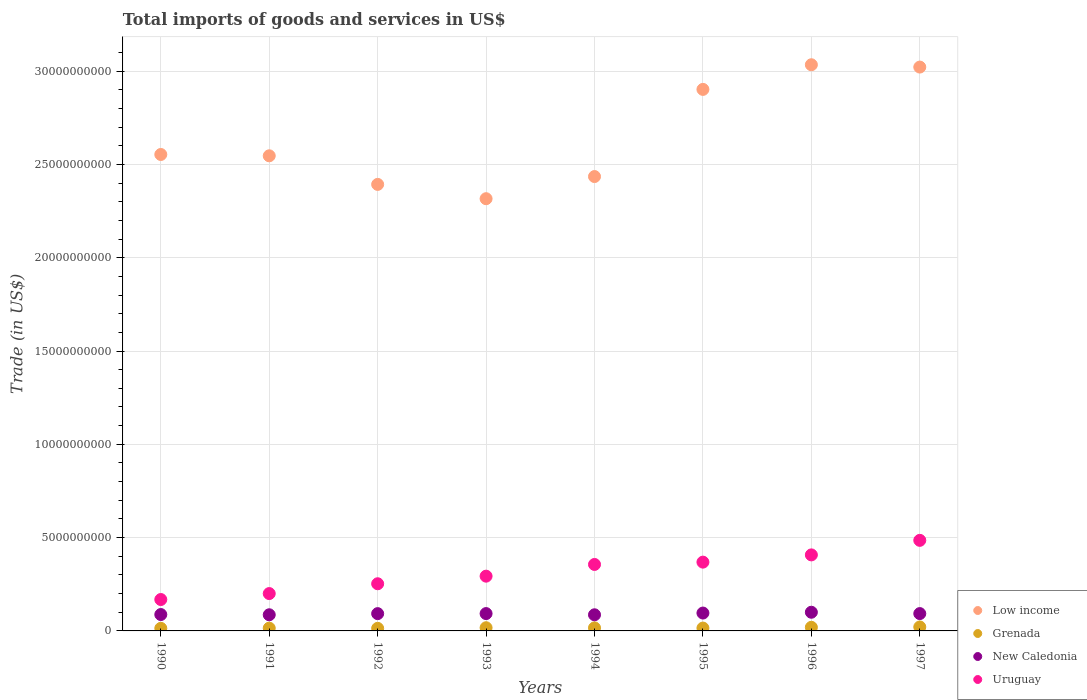What is the total imports of goods and services in Uruguay in 1991?
Offer a terse response. 2.00e+09. Across all years, what is the maximum total imports of goods and services in New Caledonia?
Offer a very short reply. 1.00e+09. Across all years, what is the minimum total imports of goods and services in New Caledonia?
Keep it short and to the point. 8.65e+08. In which year was the total imports of goods and services in New Caledonia minimum?
Offer a terse response. 1994. What is the total total imports of goods and services in Uruguay in the graph?
Your answer should be compact. 2.53e+1. What is the difference between the total imports of goods and services in Low income in 1994 and that in 1997?
Make the answer very short. -5.87e+09. What is the difference between the total imports of goods and services in Low income in 1993 and the total imports of goods and services in New Caledonia in 1995?
Your response must be concise. 2.22e+1. What is the average total imports of goods and services in Grenada per year?
Keep it short and to the point. 1.65e+08. In the year 1992, what is the difference between the total imports of goods and services in Uruguay and total imports of goods and services in Low income?
Provide a succinct answer. -2.14e+1. What is the ratio of the total imports of goods and services in Grenada in 1994 to that in 1996?
Ensure brevity in your answer.  0.84. Is the difference between the total imports of goods and services in Uruguay in 1992 and 1995 greater than the difference between the total imports of goods and services in Low income in 1992 and 1995?
Your response must be concise. Yes. What is the difference between the highest and the second highest total imports of goods and services in Grenada?
Give a very brief answer. 1.94e+07. What is the difference between the highest and the lowest total imports of goods and services in Grenada?
Keep it short and to the point. 7.43e+07. Is the total imports of goods and services in New Caledonia strictly less than the total imports of goods and services in Low income over the years?
Your response must be concise. Yes. How many dotlines are there?
Provide a short and direct response. 4. How many years are there in the graph?
Your answer should be very brief. 8. What is the difference between two consecutive major ticks on the Y-axis?
Offer a terse response. 5.00e+09. Are the values on the major ticks of Y-axis written in scientific E-notation?
Make the answer very short. No. Does the graph contain grids?
Make the answer very short. Yes. How many legend labels are there?
Provide a succinct answer. 4. How are the legend labels stacked?
Make the answer very short. Vertical. What is the title of the graph?
Offer a very short reply. Total imports of goods and services in US$. Does "Curacao" appear as one of the legend labels in the graph?
Offer a terse response. No. What is the label or title of the Y-axis?
Make the answer very short. Trade (in US$). What is the Trade (in US$) in Low income in 1990?
Make the answer very short. 2.55e+1. What is the Trade (in US$) of Grenada in 1990?
Offer a very short reply. 1.39e+08. What is the Trade (in US$) of New Caledonia in 1990?
Your answer should be compact. 8.78e+08. What is the Trade (in US$) of Uruguay in 1990?
Ensure brevity in your answer.  1.68e+09. What is the Trade (in US$) of Low income in 1991?
Provide a succinct answer. 2.55e+1. What is the Trade (in US$) in Grenada in 1991?
Provide a succinct answer. 1.49e+08. What is the Trade (in US$) of New Caledonia in 1991?
Keep it short and to the point. 8.66e+08. What is the Trade (in US$) of Uruguay in 1991?
Your response must be concise. 2.00e+09. What is the Trade (in US$) of Low income in 1992?
Keep it short and to the point. 2.39e+1. What is the Trade (in US$) of Grenada in 1992?
Offer a terse response. 1.38e+08. What is the Trade (in US$) of New Caledonia in 1992?
Keep it short and to the point. 9.26e+08. What is the Trade (in US$) in Uruguay in 1992?
Your answer should be very brief. 2.53e+09. What is the Trade (in US$) in Low income in 1993?
Provide a succinct answer. 2.32e+1. What is the Trade (in US$) in Grenada in 1993?
Ensure brevity in your answer.  1.70e+08. What is the Trade (in US$) in New Caledonia in 1993?
Ensure brevity in your answer.  9.29e+08. What is the Trade (in US$) of Uruguay in 1993?
Keep it short and to the point. 2.93e+09. What is the Trade (in US$) in Low income in 1994?
Your response must be concise. 2.43e+1. What is the Trade (in US$) in Grenada in 1994?
Provide a short and direct response. 1.63e+08. What is the Trade (in US$) of New Caledonia in 1994?
Your response must be concise. 8.65e+08. What is the Trade (in US$) of Uruguay in 1994?
Provide a short and direct response. 3.56e+09. What is the Trade (in US$) in Low income in 1995?
Your response must be concise. 2.90e+1. What is the Trade (in US$) in Grenada in 1995?
Provide a succinct answer. 1.53e+08. What is the Trade (in US$) of New Caledonia in 1995?
Offer a terse response. 9.57e+08. What is the Trade (in US$) in Uruguay in 1995?
Ensure brevity in your answer.  3.69e+09. What is the Trade (in US$) of Low income in 1996?
Ensure brevity in your answer.  3.03e+1. What is the Trade (in US$) in Grenada in 1996?
Make the answer very short. 1.93e+08. What is the Trade (in US$) in New Caledonia in 1996?
Keep it short and to the point. 1.00e+09. What is the Trade (in US$) of Uruguay in 1996?
Provide a succinct answer. 4.07e+09. What is the Trade (in US$) of Low income in 1997?
Offer a very short reply. 3.02e+1. What is the Trade (in US$) in Grenada in 1997?
Your answer should be compact. 2.13e+08. What is the Trade (in US$) in New Caledonia in 1997?
Your answer should be compact. 9.29e+08. What is the Trade (in US$) of Uruguay in 1997?
Offer a very short reply. 4.85e+09. Across all years, what is the maximum Trade (in US$) of Low income?
Make the answer very short. 3.03e+1. Across all years, what is the maximum Trade (in US$) of Grenada?
Give a very brief answer. 2.13e+08. Across all years, what is the maximum Trade (in US$) of New Caledonia?
Provide a short and direct response. 1.00e+09. Across all years, what is the maximum Trade (in US$) in Uruguay?
Offer a very short reply. 4.85e+09. Across all years, what is the minimum Trade (in US$) of Low income?
Make the answer very short. 2.32e+1. Across all years, what is the minimum Trade (in US$) of Grenada?
Your response must be concise. 1.38e+08. Across all years, what is the minimum Trade (in US$) in New Caledonia?
Your answer should be very brief. 8.65e+08. Across all years, what is the minimum Trade (in US$) in Uruguay?
Your answer should be compact. 1.68e+09. What is the total Trade (in US$) of Low income in the graph?
Offer a terse response. 2.12e+11. What is the total Trade (in US$) in Grenada in the graph?
Your answer should be compact. 1.32e+09. What is the total Trade (in US$) of New Caledonia in the graph?
Give a very brief answer. 7.35e+09. What is the total Trade (in US$) of Uruguay in the graph?
Offer a terse response. 2.53e+1. What is the difference between the Trade (in US$) in Low income in 1990 and that in 1991?
Ensure brevity in your answer.  7.06e+07. What is the difference between the Trade (in US$) in Grenada in 1990 and that in 1991?
Give a very brief answer. -1.03e+07. What is the difference between the Trade (in US$) in New Caledonia in 1990 and that in 1991?
Keep it short and to the point. 1.24e+07. What is the difference between the Trade (in US$) in Uruguay in 1990 and that in 1991?
Your answer should be compact. -3.19e+08. What is the difference between the Trade (in US$) in Low income in 1990 and that in 1992?
Provide a succinct answer. 1.60e+09. What is the difference between the Trade (in US$) of Grenada in 1990 and that in 1992?
Provide a short and direct response. 5.22e+05. What is the difference between the Trade (in US$) in New Caledonia in 1990 and that in 1992?
Offer a terse response. -4.83e+07. What is the difference between the Trade (in US$) in Uruguay in 1990 and that in 1992?
Offer a terse response. -8.45e+08. What is the difference between the Trade (in US$) of Low income in 1990 and that in 1993?
Ensure brevity in your answer.  2.37e+09. What is the difference between the Trade (in US$) in Grenada in 1990 and that in 1993?
Offer a very short reply. -3.16e+07. What is the difference between the Trade (in US$) of New Caledonia in 1990 and that in 1993?
Your answer should be very brief. -5.12e+07. What is the difference between the Trade (in US$) in Uruguay in 1990 and that in 1993?
Your answer should be very brief. -1.25e+09. What is the difference between the Trade (in US$) in Low income in 1990 and that in 1994?
Give a very brief answer. 1.18e+09. What is the difference between the Trade (in US$) of Grenada in 1990 and that in 1994?
Keep it short and to the point. -2.40e+07. What is the difference between the Trade (in US$) of New Caledonia in 1990 and that in 1994?
Make the answer very short. 1.31e+07. What is the difference between the Trade (in US$) in Uruguay in 1990 and that in 1994?
Make the answer very short. -1.88e+09. What is the difference between the Trade (in US$) in Low income in 1990 and that in 1995?
Your answer should be very brief. -3.49e+09. What is the difference between the Trade (in US$) in Grenada in 1990 and that in 1995?
Give a very brief answer. -1.39e+07. What is the difference between the Trade (in US$) in New Caledonia in 1990 and that in 1995?
Your answer should be very brief. -7.95e+07. What is the difference between the Trade (in US$) of Uruguay in 1990 and that in 1995?
Offer a terse response. -2.00e+09. What is the difference between the Trade (in US$) of Low income in 1990 and that in 1996?
Give a very brief answer. -4.81e+09. What is the difference between the Trade (in US$) in Grenada in 1990 and that in 1996?
Ensure brevity in your answer.  -5.44e+07. What is the difference between the Trade (in US$) in New Caledonia in 1990 and that in 1996?
Keep it short and to the point. -1.23e+08. What is the difference between the Trade (in US$) of Uruguay in 1990 and that in 1996?
Ensure brevity in your answer.  -2.39e+09. What is the difference between the Trade (in US$) in Low income in 1990 and that in 1997?
Provide a short and direct response. -4.68e+09. What is the difference between the Trade (in US$) in Grenada in 1990 and that in 1997?
Offer a very short reply. -7.38e+07. What is the difference between the Trade (in US$) of New Caledonia in 1990 and that in 1997?
Ensure brevity in your answer.  -5.09e+07. What is the difference between the Trade (in US$) of Uruguay in 1990 and that in 1997?
Your answer should be very brief. -3.17e+09. What is the difference between the Trade (in US$) in Low income in 1991 and that in 1992?
Keep it short and to the point. 1.53e+09. What is the difference between the Trade (in US$) in Grenada in 1991 and that in 1992?
Offer a terse response. 1.08e+07. What is the difference between the Trade (in US$) of New Caledonia in 1991 and that in 1992?
Your answer should be compact. -6.07e+07. What is the difference between the Trade (in US$) of Uruguay in 1991 and that in 1992?
Your answer should be compact. -5.26e+08. What is the difference between the Trade (in US$) in Low income in 1991 and that in 1993?
Offer a terse response. 2.30e+09. What is the difference between the Trade (in US$) of Grenada in 1991 and that in 1993?
Offer a terse response. -2.13e+07. What is the difference between the Trade (in US$) in New Caledonia in 1991 and that in 1993?
Offer a very short reply. -6.36e+07. What is the difference between the Trade (in US$) in Uruguay in 1991 and that in 1993?
Ensure brevity in your answer.  -9.33e+08. What is the difference between the Trade (in US$) in Low income in 1991 and that in 1994?
Provide a succinct answer. 1.11e+09. What is the difference between the Trade (in US$) of Grenada in 1991 and that in 1994?
Provide a succinct answer. -1.37e+07. What is the difference between the Trade (in US$) in New Caledonia in 1991 and that in 1994?
Your answer should be compact. 7.38e+05. What is the difference between the Trade (in US$) of Uruguay in 1991 and that in 1994?
Provide a succinct answer. -1.56e+09. What is the difference between the Trade (in US$) in Low income in 1991 and that in 1995?
Ensure brevity in your answer.  -3.56e+09. What is the difference between the Trade (in US$) in Grenada in 1991 and that in 1995?
Your answer should be very brief. -3.58e+06. What is the difference between the Trade (in US$) in New Caledonia in 1991 and that in 1995?
Ensure brevity in your answer.  -9.19e+07. What is the difference between the Trade (in US$) in Uruguay in 1991 and that in 1995?
Provide a succinct answer. -1.68e+09. What is the difference between the Trade (in US$) in Low income in 1991 and that in 1996?
Provide a short and direct response. -4.88e+09. What is the difference between the Trade (in US$) in Grenada in 1991 and that in 1996?
Provide a succinct answer. -4.41e+07. What is the difference between the Trade (in US$) in New Caledonia in 1991 and that in 1996?
Make the answer very short. -1.35e+08. What is the difference between the Trade (in US$) of Uruguay in 1991 and that in 1996?
Provide a short and direct response. -2.07e+09. What is the difference between the Trade (in US$) in Low income in 1991 and that in 1997?
Give a very brief answer. -4.75e+09. What is the difference between the Trade (in US$) of Grenada in 1991 and that in 1997?
Your response must be concise. -6.35e+07. What is the difference between the Trade (in US$) of New Caledonia in 1991 and that in 1997?
Give a very brief answer. -6.32e+07. What is the difference between the Trade (in US$) of Uruguay in 1991 and that in 1997?
Provide a short and direct response. -2.85e+09. What is the difference between the Trade (in US$) of Low income in 1992 and that in 1993?
Make the answer very short. 7.67e+08. What is the difference between the Trade (in US$) of Grenada in 1992 and that in 1993?
Your answer should be compact. -3.21e+07. What is the difference between the Trade (in US$) in New Caledonia in 1992 and that in 1993?
Provide a succinct answer. -2.90e+06. What is the difference between the Trade (in US$) in Uruguay in 1992 and that in 1993?
Offer a terse response. -4.07e+08. What is the difference between the Trade (in US$) in Low income in 1992 and that in 1994?
Give a very brief answer. -4.20e+08. What is the difference between the Trade (in US$) in Grenada in 1992 and that in 1994?
Offer a very short reply. -2.45e+07. What is the difference between the Trade (in US$) in New Caledonia in 1992 and that in 1994?
Your answer should be compact. 6.14e+07. What is the difference between the Trade (in US$) in Uruguay in 1992 and that in 1994?
Give a very brief answer. -1.03e+09. What is the difference between the Trade (in US$) in Low income in 1992 and that in 1995?
Your answer should be compact. -5.09e+09. What is the difference between the Trade (in US$) of Grenada in 1992 and that in 1995?
Provide a succinct answer. -1.44e+07. What is the difference between the Trade (in US$) of New Caledonia in 1992 and that in 1995?
Give a very brief answer. -3.12e+07. What is the difference between the Trade (in US$) in Uruguay in 1992 and that in 1995?
Your response must be concise. -1.16e+09. What is the difference between the Trade (in US$) of Low income in 1992 and that in 1996?
Give a very brief answer. -6.41e+09. What is the difference between the Trade (in US$) of Grenada in 1992 and that in 1996?
Your answer should be compact. -5.49e+07. What is the difference between the Trade (in US$) of New Caledonia in 1992 and that in 1996?
Offer a very short reply. -7.45e+07. What is the difference between the Trade (in US$) of Uruguay in 1992 and that in 1996?
Your answer should be very brief. -1.55e+09. What is the difference between the Trade (in US$) of Low income in 1992 and that in 1997?
Make the answer very short. -6.29e+09. What is the difference between the Trade (in US$) of Grenada in 1992 and that in 1997?
Provide a succinct answer. -7.43e+07. What is the difference between the Trade (in US$) in New Caledonia in 1992 and that in 1997?
Give a very brief answer. -2.57e+06. What is the difference between the Trade (in US$) of Uruguay in 1992 and that in 1997?
Offer a very short reply. -2.33e+09. What is the difference between the Trade (in US$) in Low income in 1993 and that in 1994?
Provide a succinct answer. -1.19e+09. What is the difference between the Trade (in US$) of Grenada in 1993 and that in 1994?
Offer a terse response. 7.60e+06. What is the difference between the Trade (in US$) in New Caledonia in 1993 and that in 1994?
Give a very brief answer. 6.43e+07. What is the difference between the Trade (in US$) in Uruguay in 1993 and that in 1994?
Offer a terse response. -6.27e+08. What is the difference between the Trade (in US$) in Low income in 1993 and that in 1995?
Provide a succinct answer. -5.86e+09. What is the difference between the Trade (in US$) in Grenada in 1993 and that in 1995?
Keep it short and to the point. 1.77e+07. What is the difference between the Trade (in US$) of New Caledonia in 1993 and that in 1995?
Your answer should be compact. -2.83e+07. What is the difference between the Trade (in US$) in Uruguay in 1993 and that in 1995?
Keep it short and to the point. -7.52e+08. What is the difference between the Trade (in US$) of Low income in 1993 and that in 1996?
Your answer should be very brief. -7.18e+09. What is the difference between the Trade (in US$) in Grenada in 1993 and that in 1996?
Provide a succinct answer. -2.28e+07. What is the difference between the Trade (in US$) of New Caledonia in 1993 and that in 1996?
Your answer should be compact. -7.16e+07. What is the difference between the Trade (in US$) of Uruguay in 1993 and that in 1996?
Give a very brief answer. -1.14e+09. What is the difference between the Trade (in US$) in Low income in 1993 and that in 1997?
Give a very brief answer. -7.05e+09. What is the difference between the Trade (in US$) in Grenada in 1993 and that in 1997?
Your answer should be compact. -4.22e+07. What is the difference between the Trade (in US$) of New Caledonia in 1993 and that in 1997?
Give a very brief answer. 3.37e+05. What is the difference between the Trade (in US$) of Uruguay in 1993 and that in 1997?
Your answer should be compact. -1.92e+09. What is the difference between the Trade (in US$) in Low income in 1994 and that in 1995?
Your answer should be very brief. -4.67e+09. What is the difference between the Trade (in US$) in Grenada in 1994 and that in 1995?
Ensure brevity in your answer.  1.01e+07. What is the difference between the Trade (in US$) in New Caledonia in 1994 and that in 1995?
Provide a short and direct response. -9.26e+07. What is the difference between the Trade (in US$) of Uruguay in 1994 and that in 1995?
Your answer should be very brief. -1.24e+08. What is the difference between the Trade (in US$) in Low income in 1994 and that in 1996?
Keep it short and to the point. -5.99e+09. What is the difference between the Trade (in US$) in Grenada in 1994 and that in 1996?
Offer a terse response. -3.04e+07. What is the difference between the Trade (in US$) of New Caledonia in 1994 and that in 1996?
Make the answer very short. -1.36e+08. What is the difference between the Trade (in US$) of Uruguay in 1994 and that in 1996?
Offer a terse response. -5.12e+08. What is the difference between the Trade (in US$) of Low income in 1994 and that in 1997?
Give a very brief answer. -5.87e+09. What is the difference between the Trade (in US$) in Grenada in 1994 and that in 1997?
Provide a short and direct response. -4.98e+07. What is the difference between the Trade (in US$) of New Caledonia in 1994 and that in 1997?
Your response must be concise. -6.40e+07. What is the difference between the Trade (in US$) in Uruguay in 1994 and that in 1997?
Offer a very short reply. -1.29e+09. What is the difference between the Trade (in US$) in Low income in 1995 and that in 1996?
Provide a succinct answer. -1.32e+09. What is the difference between the Trade (in US$) of Grenada in 1995 and that in 1996?
Offer a very short reply. -4.05e+07. What is the difference between the Trade (in US$) of New Caledonia in 1995 and that in 1996?
Make the answer very short. -4.34e+07. What is the difference between the Trade (in US$) of Uruguay in 1995 and that in 1996?
Provide a short and direct response. -3.88e+08. What is the difference between the Trade (in US$) of Low income in 1995 and that in 1997?
Offer a terse response. -1.20e+09. What is the difference between the Trade (in US$) of Grenada in 1995 and that in 1997?
Your response must be concise. -5.99e+07. What is the difference between the Trade (in US$) of New Caledonia in 1995 and that in 1997?
Your answer should be very brief. 2.86e+07. What is the difference between the Trade (in US$) of Uruguay in 1995 and that in 1997?
Your answer should be very brief. -1.17e+09. What is the difference between the Trade (in US$) of Low income in 1996 and that in 1997?
Your answer should be compact. 1.24e+08. What is the difference between the Trade (in US$) in Grenada in 1996 and that in 1997?
Provide a succinct answer. -1.94e+07. What is the difference between the Trade (in US$) of New Caledonia in 1996 and that in 1997?
Your answer should be very brief. 7.20e+07. What is the difference between the Trade (in US$) of Uruguay in 1996 and that in 1997?
Make the answer very short. -7.79e+08. What is the difference between the Trade (in US$) of Low income in 1990 and the Trade (in US$) of Grenada in 1991?
Give a very brief answer. 2.54e+1. What is the difference between the Trade (in US$) of Low income in 1990 and the Trade (in US$) of New Caledonia in 1991?
Provide a short and direct response. 2.47e+1. What is the difference between the Trade (in US$) of Low income in 1990 and the Trade (in US$) of Uruguay in 1991?
Offer a very short reply. 2.35e+1. What is the difference between the Trade (in US$) of Grenada in 1990 and the Trade (in US$) of New Caledonia in 1991?
Provide a short and direct response. -7.27e+08. What is the difference between the Trade (in US$) in Grenada in 1990 and the Trade (in US$) in Uruguay in 1991?
Ensure brevity in your answer.  -1.86e+09. What is the difference between the Trade (in US$) of New Caledonia in 1990 and the Trade (in US$) of Uruguay in 1991?
Keep it short and to the point. -1.12e+09. What is the difference between the Trade (in US$) of Low income in 1990 and the Trade (in US$) of Grenada in 1992?
Ensure brevity in your answer.  2.54e+1. What is the difference between the Trade (in US$) in Low income in 1990 and the Trade (in US$) in New Caledonia in 1992?
Your answer should be compact. 2.46e+1. What is the difference between the Trade (in US$) of Low income in 1990 and the Trade (in US$) of Uruguay in 1992?
Provide a short and direct response. 2.30e+1. What is the difference between the Trade (in US$) in Grenada in 1990 and the Trade (in US$) in New Caledonia in 1992?
Offer a very short reply. -7.87e+08. What is the difference between the Trade (in US$) in Grenada in 1990 and the Trade (in US$) in Uruguay in 1992?
Your answer should be compact. -2.39e+09. What is the difference between the Trade (in US$) in New Caledonia in 1990 and the Trade (in US$) in Uruguay in 1992?
Offer a terse response. -1.65e+09. What is the difference between the Trade (in US$) of Low income in 1990 and the Trade (in US$) of Grenada in 1993?
Your answer should be very brief. 2.54e+1. What is the difference between the Trade (in US$) in Low income in 1990 and the Trade (in US$) in New Caledonia in 1993?
Ensure brevity in your answer.  2.46e+1. What is the difference between the Trade (in US$) of Low income in 1990 and the Trade (in US$) of Uruguay in 1993?
Your answer should be very brief. 2.26e+1. What is the difference between the Trade (in US$) of Grenada in 1990 and the Trade (in US$) of New Caledonia in 1993?
Give a very brief answer. -7.90e+08. What is the difference between the Trade (in US$) of Grenada in 1990 and the Trade (in US$) of Uruguay in 1993?
Keep it short and to the point. -2.80e+09. What is the difference between the Trade (in US$) of New Caledonia in 1990 and the Trade (in US$) of Uruguay in 1993?
Give a very brief answer. -2.06e+09. What is the difference between the Trade (in US$) of Low income in 1990 and the Trade (in US$) of Grenada in 1994?
Ensure brevity in your answer.  2.54e+1. What is the difference between the Trade (in US$) of Low income in 1990 and the Trade (in US$) of New Caledonia in 1994?
Keep it short and to the point. 2.47e+1. What is the difference between the Trade (in US$) of Low income in 1990 and the Trade (in US$) of Uruguay in 1994?
Ensure brevity in your answer.  2.20e+1. What is the difference between the Trade (in US$) of Grenada in 1990 and the Trade (in US$) of New Caledonia in 1994?
Make the answer very short. -7.26e+08. What is the difference between the Trade (in US$) of Grenada in 1990 and the Trade (in US$) of Uruguay in 1994?
Your response must be concise. -3.42e+09. What is the difference between the Trade (in US$) of New Caledonia in 1990 and the Trade (in US$) of Uruguay in 1994?
Give a very brief answer. -2.68e+09. What is the difference between the Trade (in US$) of Low income in 1990 and the Trade (in US$) of Grenada in 1995?
Your response must be concise. 2.54e+1. What is the difference between the Trade (in US$) in Low income in 1990 and the Trade (in US$) in New Caledonia in 1995?
Your answer should be very brief. 2.46e+1. What is the difference between the Trade (in US$) of Low income in 1990 and the Trade (in US$) of Uruguay in 1995?
Give a very brief answer. 2.18e+1. What is the difference between the Trade (in US$) of Grenada in 1990 and the Trade (in US$) of New Caledonia in 1995?
Your response must be concise. -8.19e+08. What is the difference between the Trade (in US$) in Grenada in 1990 and the Trade (in US$) in Uruguay in 1995?
Keep it short and to the point. -3.55e+09. What is the difference between the Trade (in US$) in New Caledonia in 1990 and the Trade (in US$) in Uruguay in 1995?
Provide a short and direct response. -2.81e+09. What is the difference between the Trade (in US$) in Low income in 1990 and the Trade (in US$) in Grenada in 1996?
Your response must be concise. 2.53e+1. What is the difference between the Trade (in US$) in Low income in 1990 and the Trade (in US$) in New Caledonia in 1996?
Provide a short and direct response. 2.45e+1. What is the difference between the Trade (in US$) of Low income in 1990 and the Trade (in US$) of Uruguay in 1996?
Ensure brevity in your answer.  2.15e+1. What is the difference between the Trade (in US$) of Grenada in 1990 and the Trade (in US$) of New Caledonia in 1996?
Offer a terse response. -8.62e+08. What is the difference between the Trade (in US$) in Grenada in 1990 and the Trade (in US$) in Uruguay in 1996?
Your answer should be very brief. -3.94e+09. What is the difference between the Trade (in US$) in New Caledonia in 1990 and the Trade (in US$) in Uruguay in 1996?
Offer a terse response. -3.20e+09. What is the difference between the Trade (in US$) of Low income in 1990 and the Trade (in US$) of Grenada in 1997?
Offer a very short reply. 2.53e+1. What is the difference between the Trade (in US$) of Low income in 1990 and the Trade (in US$) of New Caledonia in 1997?
Offer a very short reply. 2.46e+1. What is the difference between the Trade (in US$) in Low income in 1990 and the Trade (in US$) in Uruguay in 1997?
Provide a succinct answer. 2.07e+1. What is the difference between the Trade (in US$) of Grenada in 1990 and the Trade (in US$) of New Caledonia in 1997?
Ensure brevity in your answer.  -7.90e+08. What is the difference between the Trade (in US$) in Grenada in 1990 and the Trade (in US$) in Uruguay in 1997?
Your answer should be compact. -4.71e+09. What is the difference between the Trade (in US$) of New Caledonia in 1990 and the Trade (in US$) of Uruguay in 1997?
Make the answer very short. -3.98e+09. What is the difference between the Trade (in US$) of Low income in 1991 and the Trade (in US$) of Grenada in 1992?
Provide a short and direct response. 2.53e+1. What is the difference between the Trade (in US$) of Low income in 1991 and the Trade (in US$) of New Caledonia in 1992?
Your answer should be very brief. 2.45e+1. What is the difference between the Trade (in US$) in Low income in 1991 and the Trade (in US$) in Uruguay in 1992?
Ensure brevity in your answer.  2.29e+1. What is the difference between the Trade (in US$) of Grenada in 1991 and the Trade (in US$) of New Caledonia in 1992?
Make the answer very short. -7.77e+08. What is the difference between the Trade (in US$) in Grenada in 1991 and the Trade (in US$) in Uruguay in 1992?
Offer a terse response. -2.38e+09. What is the difference between the Trade (in US$) in New Caledonia in 1991 and the Trade (in US$) in Uruguay in 1992?
Your answer should be very brief. -1.66e+09. What is the difference between the Trade (in US$) of Low income in 1991 and the Trade (in US$) of Grenada in 1993?
Provide a succinct answer. 2.53e+1. What is the difference between the Trade (in US$) of Low income in 1991 and the Trade (in US$) of New Caledonia in 1993?
Keep it short and to the point. 2.45e+1. What is the difference between the Trade (in US$) in Low income in 1991 and the Trade (in US$) in Uruguay in 1993?
Keep it short and to the point. 2.25e+1. What is the difference between the Trade (in US$) in Grenada in 1991 and the Trade (in US$) in New Caledonia in 1993?
Give a very brief answer. -7.80e+08. What is the difference between the Trade (in US$) in Grenada in 1991 and the Trade (in US$) in Uruguay in 1993?
Provide a succinct answer. -2.79e+09. What is the difference between the Trade (in US$) in New Caledonia in 1991 and the Trade (in US$) in Uruguay in 1993?
Your answer should be compact. -2.07e+09. What is the difference between the Trade (in US$) of Low income in 1991 and the Trade (in US$) of Grenada in 1994?
Your response must be concise. 2.53e+1. What is the difference between the Trade (in US$) in Low income in 1991 and the Trade (in US$) in New Caledonia in 1994?
Provide a succinct answer. 2.46e+1. What is the difference between the Trade (in US$) of Low income in 1991 and the Trade (in US$) of Uruguay in 1994?
Keep it short and to the point. 2.19e+1. What is the difference between the Trade (in US$) of Grenada in 1991 and the Trade (in US$) of New Caledonia in 1994?
Give a very brief answer. -7.16e+08. What is the difference between the Trade (in US$) in Grenada in 1991 and the Trade (in US$) in Uruguay in 1994?
Offer a very short reply. -3.41e+09. What is the difference between the Trade (in US$) in New Caledonia in 1991 and the Trade (in US$) in Uruguay in 1994?
Your answer should be compact. -2.70e+09. What is the difference between the Trade (in US$) of Low income in 1991 and the Trade (in US$) of Grenada in 1995?
Your answer should be compact. 2.53e+1. What is the difference between the Trade (in US$) of Low income in 1991 and the Trade (in US$) of New Caledonia in 1995?
Your response must be concise. 2.45e+1. What is the difference between the Trade (in US$) of Low income in 1991 and the Trade (in US$) of Uruguay in 1995?
Offer a very short reply. 2.18e+1. What is the difference between the Trade (in US$) in Grenada in 1991 and the Trade (in US$) in New Caledonia in 1995?
Make the answer very short. -8.08e+08. What is the difference between the Trade (in US$) of Grenada in 1991 and the Trade (in US$) of Uruguay in 1995?
Offer a terse response. -3.54e+09. What is the difference between the Trade (in US$) in New Caledonia in 1991 and the Trade (in US$) in Uruguay in 1995?
Offer a terse response. -2.82e+09. What is the difference between the Trade (in US$) of Low income in 1991 and the Trade (in US$) of Grenada in 1996?
Give a very brief answer. 2.53e+1. What is the difference between the Trade (in US$) in Low income in 1991 and the Trade (in US$) in New Caledonia in 1996?
Make the answer very short. 2.45e+1. What is the difference between the Trade (in US$) in Low income in 1991 and the Trade (in US$) in Uruguay in 1996?
Keep it short and to the point. 2.14e+1. What is the difference between the Trade (in US$) of Grenada in 1991 and the Trade (in US$) of New Caledonia in 1996?
Provide a short and direct response. -8.52e+08. What is the difference between the Trade (in US$) in Grenada in 1991 and the Trade (in US$) in Uruguay in 1996?
Your answer should be very brief. -3.92e+09. What is the difference between the Trade (in US$) of New Caledonia in 1991 and the Trade (in US$) of Uruguay in 1996?
Provide a short and direct response. -3.21e+09. What is the difference between the Trade (in US$) of Low income in 1991 and the Trade (in US$) of Grenada in 1997?
Give a very brief answer. 2.52e+1. What is the difference between the Trade (in US$) of Low income in 1991 and the Trade (in US$) of New Caledonia in 1997?
Keep it short and to the point. 2.45e+1. What is the difference between the Trade (in US$) of Low income in 1991 and the Trade (in US$) of Uruguay in 1997?
Provide a succinct answer. 2.06e+1. What is the difference between the Trade (in US$) in Grenada in 1991 and the Trade (in US$) in New Caledonia in 1997?
Offer a very short reply. -7.80e+08. What is the difference between the Trade (in US$) in Grenada in 1991 and the Trade (in US$) in Uruguay in 1997?
Ensure brevity in your answer.  -4.70e+09. What is the difference between the Trade (in US$) of New Caledonia in 1991 and the Trade (in US$) of Uruguay in 1997?
Keep it short and to the point. -3.99e+09. What is the difference between the Trade (in US$) of Low income in 1992 and the Trade (in US$) of Grenada in 1993?
Your response must be concise. 2.38e+1. What is the difference between the Trade (in US$) in Low income in 1992 and the Trade (in US$) in New Caledonia in 1993?
Your answer should be compact. 2.30e+1. What is the difference between the Trade (in US$) in Low income in 1992 and the Trade (in US$) in Uruguay in 1993?
Give a very brief answer. 2.10e+1. What is the difference between the Trade (in US$) of Grenada in 1992 and the Trade (in US$) of New Caledonia in 1993?
Your answer should be very brief. -7.91e+08. What is the difference between the Trade (in US$) of Grenada in 1992 and the Trade (in US$) of Uruguay in 1993?
Make the answer very short. -2.80e+09. What is the difference between the Trade (in US$) of New Caledonia in 1992 and the Trade (in US$) of Uruguay in 1993?
Your answer should be compact. -2.01e+09. What is the difference between the Trade (in US$) in Low income in 1992 and the Trade (in US$) in Grenada in 1994?
Ensure brevity in your answer.  2.38e+1. What is the difference between the Trade (in US$) of Low income in 1992 and the Trade (in US$) of New Caledonia in 1994?
Make the answer very short. 2.31e+1. What is the difference between the Trade (in US$) in Low income in 1992 and the Trade (in US$) in Uruguay in 1994?
Your answer should be very brief. 2.04e+1. What is the difference between the Trade (in US$) in Grenada in 1992 and the Trade (in US$) in New Caledonia in 1994?
Provide a short and direct response. -7.27e+08. What is the difference between the Trade (in US$) of Grenada in 1992 and the Trade (in US$) of Uruguay in 1994?
Your answer should be very brief. -3.42e+09. What is the difference between the Trade (in US$) of New Caledonia in 1992 and the Trade (in US$) of Uruguay in 1994?
Your answer should be compact. -2.64e+09. What is the difference between the Trade (in US$) in Low income in 1992 and the Trade (in US$) in Grenada in 1995?
Ensure brevity in your answer.  2.38e+1. What is the difference between the Trade (in US$) in Low income in 1992 and the Trade (in US$) in New Caledonia in 1995?
Ensure brevity in your answer.  2.30e+1. What is the difference between the Trade (in US$) of Low income in 1992 and the Trade (in US$) of Uruguay in 1995?
Your answer should be very brief. 2.02e+1. What is the difference between the Trade (in US$) of Grenada in 1992 and the Trade (in US$) of New Caledonia in 1995?
Your response must be concise. -8.19e+08. What is the difference between the Trade (in US$) in Grenada in 1992 and the Trade (in US$) in Uruguay in 1995?
Provide a succinct answer. -3.55e+09. What is the difference between the Trade (in US$) of New Caledonia in 1992 and the Trade (in US$) of Uruguay in 1995?
Ensure brevity in your answer.  -2.76e+09. What is the difference between the Trade (in US$) of Low income in 1992 and the Trade (in US$) of Grenada in 1996?
Provide a short and direct response. 2.37e+1. What is the difference between the Trade (in US$) in Low income in 1992 and the Trade (in US$) in New Caledonia in 1996?
Keep it short and to the point. 2.29e+1. What is the difference between the Trade (in US$) in Low income in 1992 and the Trade (in US$) in Uruguay in 1996?
Make the answer very short. 1.99e+1. What is the difference between the Trade (in US$) of Grenada in 1992 and the Trade (in US$) of New Caledonia in 1996?
Your answer should be compact. -8.63e+08. What is the difference between the Trade (in US$) in Grenada in 1992 and the Trade (in US$) in Uruguay in 1996?
Offer a very short reply. -3.94e+09. What is the difference between the Trade (in US$) in New Caledonia in 1992 and the Trade (in US$) in Uruguay in 1996?
Ensure brevity in your answer.  -3.15e+09. What is the difference between the Trade (in US$) in Low income in 1992 and the Trade (in US$) in Grenada in 1997?
Provide a succinct answer. 2.37e+1. What is the difference between the Trade (in US$) in Low income in 1992 and the Trade (in US$) in New Caledonia in 1997?
Your answer should be very brief. 2.30e+1. What is the difference between the Trade (in US$) of Low income in 1992 and the Trade (in US$) of Uruguay in 1997?
Provide a short and direct response. 1.91e+1. What is the difference between the Trade (in US$) of Grenada in 1992 and the Trade (in US$) of New Caledonia in 1997?
Your answer should be very brief. -7.91e+08. What is the difference between the Trade (in US$) of Grenada in 1992 and the Trade (in US$) of Uruguay in 1997?
Offer a very short reply. -4.72e+09. What is the difference between the Trade (in US$) of New Caledonia in 1992 and the Trade (in US$) of Uruguay in 1997?
Provide a short and direct response. -3.93e+09. What is the difference between the Trade (in US$) in Low income in 1993 and the Trade (in US$) in Grenada in 1994?
Ensure brevity in your answer.  2.30e+1. What is the difference between the Trade (in US$) in Low income in 1993 and the Trade (in US$) in New Caledonia in 1994?
Keep it short and to the point. 2.23e+1. What is the difference between the Trade (in US$) of Low income in 1993 and the Trade (in US$) of Uruguay in 1994?
Your response must be concise. 1.96e+1. What is the difference between the Trade (in US$) of Grenada in 1993 and the Trade (in US$) of New Caledonia in 1994?
Your answer should be very brief. -6.94e+08. What is the difference between the Trade (in US$) in Grenada in 1993 and the Trade (in US$) in Uruguay in 1994?
Your answer should be very brief. -3.39e+09. What is the difference between the Trade (in US$) of New Caledonia in 1993 and the Trade (in US$) of Uruguay in 1994?
Give a very brief answer. -2.63e+09. What is the difference between the Trade (in US$) of Low income in 1993 and the Trade (in US$) of Grenada in 1995?
Your answer should be compact. 2.30e+1. What is the difference between the Trade (in US$) of Low income in 1993 and the Trade (in US$) of New Caledonia in 1995?
Your answer should be compact. 2.22e+1. What is the difference between the Trade (in US$) of Low income in 1993 and the Trade (in US$) of Uruguay in 1995?
Your answer should be very brief. 1.95e+1. What is the difference between the Trade (in US$) of Grenada in 1993 and the Trade (in US$) of New Caledonia in 1995?
Ensure brevity in your answer.  -7.87e+08. What is the difference between the Trade (in US$) in Grenada in 1993 and the Trade (in US$) in Uruguay in 1995?
Make the answer very short. -3.52e+09. What is the difference between the Trade (in US$) of New Caledonia in 1993 and the Trade (in US$) of Uruguay in 1995?
Your answer should be very brief. -2.76e+09. What is the difference between the Trade (in US$) in Low income in 1993 and the Trade (in US$) in Grenada in 1996?
Offer a terse response. 2.30e+1. What is the difference between the Trade (in US$) of Low income in 1993 and the Trade (in US$) of New Caledonia in 1996?
Make the answer very short. 2.22e+1. What is the difference between the Trade (in US$) in Low income in 1993 and the Trade (in US$) in Uruguay in 1996?
Your answer should be very brief. 1.91e+1. What is the difference between the Trade (in US$) of Grenada in 1993 and the Trade (in US$) of New Caledonia in 1996?
Give a very brief answer. -8.30e+08. What is the difference between the Trade (in US$) in Grenada in 1993 and the Trade (in US$) in Uruguay in 1996?
Your answer should be very brief. -3.90e+09. What is the difference between the Trade (in US$) in New Caledonia in 1993 and the Trade (in US$) in Uruguay in 1996?
Offer a terse response. -3.14e+09. What is the difference between the Trade (in US$) in Low income in 1993 and the Trade (in US$) in Grenada in 1997?
Provide a succinct answer. 2.29e+1. What is the difference between the Trade (in US$) in Low income in 1993 and the Trade (in US$) in New Caledonia in 1997?
Make the answer very short. 2.22e+1. What is the difference between the Trade (in US$) of Low income in 1993 and the Trade (in US$) of Uruguay in 1997?
Your answer should be compact. 1.83e+1. What is the difference between the Trade (in US$) in Grenada in 1993 and the Trade (in US$) in New Caledonia in 1997?
Provide a short and direct response. -7.58e+08. What is the difference between the Trade (in US$) in Grenada in 1993 and the Trade (in US$) in Uruguay in 1997?
Your response must be concise. -4.68e+09. What is the difference between the Trade (in US$) of New Caledonia in 1993 and the Trade (in US$) of Uruguay in 1997?
Your answer should be very brief. -3.92e+09. What is the difference between the Trade (in US$) of Low income in 1994 and the Trade (in US$) of Grenada in 1995?
Your response must be concise. 2.42e+1. What is the difference between the Trade (in US$) of Low income in 1994 and the Trade (in US$) of New Caledonia in 1995?
Provide a short and direct response. 2.34e+1. What is the difference between the Trade (in US$) of Low income in 1994 and the Trade (in US$) of Uruguay in 1995?
Make the answer very short. 2.07e+1. What is the difference between the Trade (in US$) in Grenada in 1994 and the Trade (in US$) in New Caledonia in 1995?
Ensure brevity in your answer.  -7.95e+08. What is the difference between the Trade (in US$) of Grenada in 1994 and the Trade (in US$) of Uruguay in 1995?
Your answer should be compact. -3.52e+09. What is the difference between the Trade (in US$) of New Caledonia in 1994 and the Trade (in US$) of Uruguay in 1995?
Ensure brevity in your answer.  -2.82e+09. What is the difference between the Trade (in US$) of Low income in 1994 and the Trade (in US$) of Grenada in 1996?
Provide a succinct answer. 2.42e+1. What is the difference between the Trade (in US$) in Low income in 1994 and the Trade (in US$) in New Caledonia in 1996?
Ensure brevity in your answer.  2.33e+1. What is the difference between the Trade (in US$) in Low income in 1994 and the Trade (in US$) in Uruguay in 1996?
Ensure brevity in your answer.  2.03e+1. What is the difference between the Trade (in US$) of Grenada in 1994 and the Trade (in US$) of New Caledonia in 1996?
Ensure brevity in your answer.  -8.38e+08. What is the difference between the Trade (in US$) in Grenada in 1994 and the Trade (in US$) in Uruguay in 1996?
Keep it short and to the point. -3.91e+09. What is the difference between the Trade (in US$) of New Caledonia in 1994 and the Trade (in US$) of Uruguay in 1996?
Give a very brief answer. -3.21e+09. What is the difference between the Trade (in US$) of Low income in 1994 and the Trade (in US$) of Grenada in 1997?
Your response must be concise. 2.41e+1. What is the difference between the Trade (in US$) in Low income in 1994 and the Trade (in US$) in New Caledonia in 1997?
Keep it short and to the point. 2.34e+1. What is the difference between the Trade (in US$) of Low income in 1994 and the Trade (in US$) of Uruguay in 1997?
Keep it short and to the point. 1.95e+1. What is the difference between the Trade (in US$) of Grenada in 1994 and the Trade (in US$) of New Caledonia in 1997?
Your response must be concise. -7.66e+08. What is the difference between the Trade (in US$) of Grenada in 1994 and the Trade (in US$) of Uruguay in 1997?
Ensure brevity in your answer.  -4.69e+09. What is the difference between the Trade (in US$) in New Caledonia in 1994 and the Trade (in US$) in Uruguay in 1997?
Give a very brief answer. -3.99e+09. What is the difference between the Trade (in US$) in Low income in 1995 and the Trade (in US$) in Grenada in 1996?
Offer a very short reply. 2.88e+1. What is the difference between the Trade (in US$) in Low income in 1995 and the Trade (in US$) in New Caledonia in 1996?
Your response must be concise. 2.80e+1. What is the difference between the Trade (in US$) of Low income in 1995 and the Trade (in US$) of Uruguay in 1996?
Keep it short and to the point. 2.49e+1. What is the difference between the Trade (in US$) of Grenada in 1995 and the Trade (in US$) of New Caledonia in 1996?
Offer a terse response. -8.48e+08. What is the difference between the Trade (in US$) in Grenada in 1995 and the Trade (in US$) in Uruguay in 1996?
Offer a terse response. -3.92e+09. What is the difference between the Trade (in US$) in New Caledonia in 1995 and the Trade (in US$) in Uruguay in 1996?
Offer a terse response. -3.12e+09. What is the difference between the Trade (in US$) in Low income in 1995 and the Trade (in US$) in Grenada in 1997?
Provide a short and direct response. 2.88e+1. What is the difference between the Trade (in US$) of Low income in 1995 and the Trade (in US$) of New Caledonia in 1997?
Your answer should be very brief. 2.81e+1. What is the difference between the Trade (in US$) of Low income in 1995 and the Trade (in US$) of Uruguay in 1997?
Your answer should be very brief. 2.42e+1. What is the difference between the Trade (in US$) of Grenada in 1995 and the Trade (in US$) of New Caledonia in 1997?
Give a very brief answer. -7.76e+08. What is the difference between the Trade (in US$) of Grenada in 1995 and the Trade (in US$) of Uruguay in 1997?
Your response must be concise. -4.70e+09. What is the difference between the Trade (in US$) of New Caledonia in 1995 and the Trade (in US$) of Uruguay in 1997?
Provide a succinct answer. -3.90e+09. What is the difference between the Trade (in US$) in Low income in 1996 and the Trade (in US$) in Grenada in 1997?
Give a very brief answer. 3.01e+1. What is the difference between the Trade (in US$) of Low income in 1996 and the Trade (in US$) of New Caledonia in 1997?
Provide a succinct answer. 2.94e+1. What is the difference between the Trade (in US$) of Low income in 1996 and the Trade (in US$) of Uruguay in 1997?
Your answer should be very brief. 2.55e+1. What is the difference between the Trade (in US$) of Grenada in 1996 and the Trade (in US$) of New Caledonia in 1997?
Offer a very short reply. -7.36e+08. What is the difference between the Trade (in US$) of Grenada in 1996 and the Trade (in US$) of Uruguay in 1997?
Ensure brevity in your answer.  -4.66e+09. What is the difference between the Trade (in US$) in New Caledonia in 1996 and the Trade (in US$) in Uruguay in 1997?
Keep it short and to the point. -3.85e+09. What is the average Trade (in US$) in Low income per year?
Offer a terse response. 2.65e+1. What is the average Trade (in US$) in Grenada per year?
Keep it short and to the point. 1.65e+08. What is the average Trade (in US$) in New Caledonia per year?
Offer a terse response. 9.19e+08. What is the average Trade (in US$) of Uruguay per year?
Offer a terse response. 3.17e+09. In the year 1990, what is the difference between the Trade (in US$) of Low income and Trade (in US$) of Grenada?
Give a very brief answer. 2.54e+1. In the year 1990, what is the difference between the Trade (in US$) of Low income and Trade (in US$) of New Caledonia?
Keep it short and to the point. 2.47e+1. In the year 1990, what is the difference between the Trade (in US$) of Low income and Trade (in US$) of Uruguay?
Make the answer very short. 2.38e+1. In the year 1990, what is the difference between the Trade (in US$) of Grenada and Trade (in US$) of New Caledonia?
Ensure brevity in your answer.  -7.39e+08. In the year 1990, what is the difference between the Trade (in US$) in Grenada and Trade (in US$) in Uruguay?
Your answer should be very brief. -1.54e+09. In the year 1990, what is the difference between the Trade (in US$) in New Caledonia and Trade (in US$) in Uruguay?
Your answer should be very brief. -8.05e+08. In the year 1991, what is the difference between the Trade (in US$) of Low income and Trade (in US$) of Grenada?
Make the answer very short. 2.53e+1. In the year 1991, what is the difference between the Trade (in US$) in Low income and Trade (in US$) in New Caledonia?
Keep it short and to the point. 2.46e+1. In the year 1991, what is the difference between the Trade (in US$) in Low income and Trade (in US$) in Uruguay?
Your answer should be very brief. 2.35e+1. In the year 1991, what is the difference between the Trade (in US$) of Grenada and Trade (in US$) of New Caledonia?
Provide a succinct answer. -7.16e+08. In the year 1991, what is the difference between the Trade (in US$) in Grenada and Trade (in US$) in Uruguay?
Keep it short and to the point. -1.85e+09. In the year 1991, what is the difference between the Trade (in US$) in New Caledonia and Trade (in US$) in Uruguay?
Your response must be concise. -1.14e+09. In the year 1992, what is the difference between the Trade (in US$) of Low income and Trade (in US$) of Grenada?
Offer a very short reply. 2.38e+1. In the year 1992, what is the difference between the Trade (in US$) in Low income and Trade (in US$) in New Caledonia?
Ensure brevity in your answer.  2.30e+1. In the year 1992, what is the difference between the Trade (in US$) of Low income and Trade (in US$) of Uruguay?
Provide a succinct answer. 2.14e+1. In the year 1992, what is the difference between the Trade (in US$) of Grenada and Trade (in US$) of New Caledonia?
Your answer should be compact. -7.88e+08. In the year 1992, what is the difference between the Trade (in US$) of Grenada and Trade (in US$) of Uruguay?
Ensure brevity in your answer.  -2.39e+09. In the year 1992, what is the difference between the Trade (in US$) in New Caledonia and Trade (in US$) in Uruguay?
Provide a short and direct response. -1.60e+09. In the year 1993, what is the difference between the Trade (in US$) in Low income and Trade (in US$) in Grenada?
Keep it short and to the point. 2.30e+1. In the year 1993, what is the difference between the Trade (in US$) in Low income and Trade (in US$) in New Caledonia?
Your answer should be compact. 2.22e+1. In the year 1993, what is the difference between the Trade (in US$) in Low income and Trade (in US$) in Uruguay?
Give a very brief answer. 2.02e+1. In the year 1993, what is the difference between the Trade (in US$) of Grenada and Trade (in US$) of New Caledonia?
Keep it short and to the point. -7.59e+08. In the year 1993, what is the difference between the Trade (in US$) of Grenada and Trade (in US$) of Uruguay?
Provide a short and direct response. -2.76e+09. In the year 1993, what is the difference between the Trade (in US$) in New Caledonia and Trade (in US$) in Uruguay?
Your answer should be very brief. -2.01e+09. In the year 1994, what is the difference between the Trade (in US$) of Low income and Trade (in US$) of Grenada?
Keep it short and to the point. 2.42e+1. In the year 1994, what is the difference between the Trade (in US$) of Low income and Trade (in US$) of New Caledonia?
Give a very brief answer. 2.35e+1. In the year 1994, what is the difference between the Trade (in US$) of Low income and Trade (in US$) of Uruguay?
Your answer should be very brief. 2.08e+1. In the year 1994, what is the difference between the Trade (in US$) of Grenada and Trade (in US$) of New Caledonia?
Provide a succinct answer. -7.02e+08. In the year 1994, what is the difference between the Trade (in US$) in Grenada and Trade (in US$) in Uruguay?
Give a very brief answer. -3.40e+09. In the year 1994, what is the difference between the Trade (in US$) in New Caledonia and Trade (in US$) in Uruguay?
Ensure brevity in your answer.  -2.70e+09. In the year 1995, what is the difference between the Trade (in US$) in Low income and Trade (in US$) in Grenada?
Offer a terse response. 2.89e+1. In the year 1995, what is the difference between the Trade (in US$) of Low income and Trade (in US$) of New Caledonia?
Offer a terse response. 2.81e+1. In the year 1995, what is the difference between the Trade (in US$) in Low income and Trade (in US$) in Uruguay?
Your answer should be compact. 2.53e+1. In the year 1995, what is the difference between the Trade (in US$) of Grenada and Trade (in US$) of New Caledonia?
Offer a very short reply. -8.05e+08. In the year 1995, what is the difference between the Trade (in US$) of Grenada and Trade (in US$) of Uruguay?
Give a very brief answer. -3.53e+09. In the year 1995, what is the difference between the Trade (in US$) in New Caledonia and Trade (in US$) in Uruguay?
Your answer should be compact. -2.73e+09. In the year 1996, what is the difference between the Trade (in US$) of Low income and Trade (in US$) of Grenada?
Provide a short and direct response. 3.01e+1. In the year 1996, what is the difference between the Trade (in US$) of Low income and Trade (in US$) of New Caledonia?
Your answer should be very brief. 2.93e+1. In the year 1996, what is the difference between the Trade (in US$) of Low income and Trade (in US$) of Uruguay?
Provide a short and direct response. 2.63e+1. In the year 1996, what is the difference between the Trade (in US$) in Grenada and Trade (in US$) in New Caledonia?
Your response must be concise. -8.08e+08. In the year 1996, what is the difference between the Trade (in US$) in Grenada and Trade (in US$) in Uruguay?
Your response must be concise. -3.88e+09. In the year 1996, what is the difference between the Trade (in US$) of New Caledonia and Trade (in US$) of Uruguay?
Your answer should be very brief. -3.07e+09. In the year 1997, what is the difference between the Trade (in US$) in Low income and Trade (in US$) in Grenada?
Your answer should be very brief. 3.00e+1. In the year 1997, what is the difference between the Trade (in US$) of Low income and Trade (in US$) of New Caledonia?
Ensure brevity in your answer.  2.93e+1. In the year 1997, what is the difference between the Trade (in US$) in Low income and Trade (in US$) in Uruguay?
Make the answer very short. 2.54e+1. In the year 1997, what is the difference between the Trade (in US$) in Grenada and Trade (in US$) in New Caledonia?
Give a very brief answer. -7.16e+08. In the year 1997, what is the difference between the Trade (in US$) in Grenada and Trade (in US$) in Uruguay?
Give a very brief answer. -4.64e+09. In the year 1997, what is the difference between the Trade (in US$) of New Caledonia and Trade (in US$) of Uruguay?
Your answer should be compact. -3.92e+09. What is the ratio of the Trade (in US$) in Low income in 1990 to that in 1991?
Keep it short and to the point. 1. What is the ratio of the Trade (in US$) of Grenada in 1990 to that in 1991?
Provide a succinct answer. 0.93. What is the ratio of the Trade (in US$) in New Caledonia in 1990 to that in 1991?
Ensure brevity in your answer.  1.01. What is the ratio of the Trade (in US$) in Uruguay in 1990 to that in 1991?
Offer a terse response. 0.84. What is the ratio of the Trade (in US$) in Low income in 1990 to that in 1992?
Offer a very short reply. 1.07. What is the ratio of the Trade (in US$) of Grenada in 1990 to that in 1992?
Provide a short and direct response. 1. What is the ratio of the Trade (in US$) of New Caledonia in 1990 to that in 1992?
Provide a short and direct response. 0.95. What is the ratio of the Trade (in US$) of Uruguay in 1990 to that in 1992?
Offer a terse response. 0.67. What is the ratio of the Trade (in US$) in Low income in 1990 to that in 1993?
Keep it short and to the point. 1.1. What is the ratio of the Trade (in US$) in Grenada in 1990 to that in 1993?
Your answer should be very brief. 0.81. What is the ratio of the Trade (in US$) in New Caledonia in 1990 to that in 1993?
Your response must be concise. 0.94. What is the ratio of the Trade (in US$) of Uruguay in 1990 to that in 1993?
Offer a very short reply. 0.57. What is the ratio of the Trade (in US$) in Low income in 1990 to that in 1994?
Keep it short and to the point. 1.05. What is the ratio of the Trade (in US$) of Grenada in 1990 to that in 1994?
Provide a short and direct response. 0.85. What is the ratio of the Trade (in US$) of New Caledonia in 1990 to that in 1994?
Provide a succinct answer. 1.02. What is the ratio of the Trade (in US$) of Uruguay in 1990 to that in 1994?
Your answer should be very brief. 0.47. What is the ratio of the Trade (in US$) of Low income in 1990 to that in 1995?
Your response must be concise. 0.88. What is the ratio of the Trade (in US$) in Grenada in 1990 to that in 1995?
Your answer should be compact. 0.91. What is the ratio of the Trade (in US$) of New Caledonia in 1990 to that in 1995?
Keep it short and to the point. 0.92. What is the ratio of the Trade (in US$) of Uruguay in 1990 to that in 1995?
Provide a short and direct response. 0.46. What is the ratio of the Trade (in US$) in Low income in 1990 to that in 1996?
Give a very brief answer. 0.84. What is the ratio of the Trade (in US$) of Grenada in 1990 to that in 1996?
Offer a very short reply. 0.72. What is the ratio of the Trade (in US$) of New Caledonia in 1990 to that in 1996?
Ensure brevity in your answer.  0.88. What is the ratio of the Trade (in US$) in Uruguay in 1990 to that in 1996?
Your answer should be very brief. 0.41. What is the ratio of the Trade (in US$) in Low income in 1990 to that in 1997?
Make the answer very short. 0.84. What is the ratio of the Trade (in US$) of Grenada in 1990 to that in 1997?
Offer a very short reply. 0.65. What is the ratio of the Trade (in US$) of New Caledonia in 1990 to that in 1997?
Offer a terse response. 0.95. What is the ratio of the Trade (in US$) of Uruguay in 1990 to that in 1997?
Make the answer very short. 0.35. What is the ratio of the Trade (in US$) in Low income in 1991 to that in 1992?
Offer a very short reply. 1.06. What is the ratio of the Trade (in US$) in Grenada in 1991 to that in 1992?
Offer a very short reply. 1.08. What is the ratio of the Trade (in US$) in New Caledonia in 1991 to that in 1992?
Offer a very short reply. 0.93. What is the ratio of the Trade (in US$) of Uruguay in 1991 to that in 1992?
Your answer should be compact. 0.79. What is the ratio of the Trade (in US$) in Low income in 1991 to that in 1993?
Your response must be concise. 1.1. What is the ratio of the Trade (in US$) in Grenada in 1991 to that in 1993?
Make the answer very short. 0.88. What is the ratio of the Trade (in US$) in New Caledonia in 1991 to that in 1993?
Offer a terse response. 0.93. What is the ratio of the Trade (in US$) of Uruguay in 1991 to that in 1993?
Your answer should be compact. 0.68. What is the ratio of the Trade (in US$) in Low income in 1991 to that in 1994?
Give a very brief answer. 1.05. What is the ratio of the Trade (in US$) of Grenada in 1991 to that in 1994?
Keep it short and to the point. 0.92. What is the ratio of the Trade (in US$) in Uruguay in 1991 to that in 1994?
Provide a succinct answer. 0.56. What is the ratio of the Trade (in US$) in Low income in 1991 to that in 1995?
Your response must be concise. 0.88. What is the ratio of the Trade (in US$) in Grenada in 1991 to that in 1995?
Offer a terse response. 0.98. What is the ratio of the Trade (in US$) in New Caledonia in 1991 to that in 1995?
Your answer should be very brief. 0.9. What is the ratio of the Trade (in US$) in Uruguay in 1991 to that in 1995?
Make the answer very short. 0.54. What is the ratio of the Trade (in US$) in Low income in 1991 to that in 1996?
Provide a succinct answer. 0.84. What is the ratio of the Trade (in US$) of Grenada in 1991 to that in 1996?
Provide a short and direct response. 0.77. What is the ratio of the Trade (in US$) of New Caledonia in 1991 to that in 1996?
Your answer should be compact. 0.86. What is the ratio of the Trade (in US$) in Uruguay in 1991 to that in 1996?
Make the answer very short. 0.49. What is the ratio of the Trade (in US$) in Low income in 1991 to that in 1997?
Provide a succinct answer. 0.84. What is the ratio of the Trade (in US$) in Grenada in 1991 to that in 1997?
Provide a short and direct response. 0.7. What is the ratio of the Trade (in US$) in New Caledonia in 1991 to that in 1997?
Your response must be concise. 0.93. What is the ratio of the Trade (in US$) in Uruguay in 1991 to that in 1997?
Keep it short and to the point. 0.41. What is the ratio of the Trade (in US$) of Low income in 1992 to that in 1993?
Give a very brief answer. 1.03. What is the ratio of the Trade (in US$) in Grenada in 1992 to that in 1993?
Offer a very short reply. 0.81. What is the ratio of the Trade (in US$) of New Caledonia in 1992 to that in 1993?
Offer a terse response. 1. What is the ratio of the Trade (in US$) of Uruguay in 1992 to that in 1993?
Keep it short and to the point. 0.86. What is the ratio of the Trade (in US$) of Low income in 1992 to that in 1994?
Provide a succinct answer. 0.98. What is the ratio of the Trade (in US$) of Grenada in 1992 to that in 1994?
Offer a terse response. 0.85. What is the ratio of the Trade (in US$) in New Caledonia in 1992 to that in 1994?
Your response must be concise. 1.07. What is the ratio of the Trade (in US$) of Uruguay in 1992 to that in 1994?
Your answer should be very brief. 0.71. What is the ratio of the Trade (in US$) of Low income in 1992 to that in 1995?
Your answer should be very brief. 0.82. What is the ratio of the Trade (in US$) in Grenada in 1992 to that in 1995?
Keep it short and to the point. 0.91. What is the ratio of the Trade (in US$) of New Caledonia in 1992 to that in 1995?
Ensure brevity in your answer.  0.97. What is the ratio of the Trade (in US$) of Uruguay in 1992 to that in 1995?
Offer a terse response. 0.69. What is the ratio of the Trade (in US$) of Low income in 1992 to that in 1996?
Make the answer very short. 0.79. What is the ratio of the Trade (in US$) in Grenada in 1992 to that in 1996?
Your response must be concise. 0.72. What is the ratio of the Trade (in US$) in New Caledonia in 1992 to that in 1996?
Give a very brief answer. 0.93. What is the ratio of the Trade (in US$) of Uruguay in 1992 to that in 1996?
Keep it short and to the point. 0.62. What is the ratio of the Trade (in US$) of Low income in 1992 to that in 1997?
Your answer should be compact. 0.79. What is the ratio of the Trade (in US$) in Grenada in 1992 to that in 1997?
Keep it short and to the point. 0.65. What is the ratio of the Trade (in US$) in Uruguay in 1992 to that in 1997?
Give a very brief answer. 0.52. What is the ratio of the Trade (in US$) in Low income in 1993 to that in 1994?
Make the answer very short. 0.95. What is the ratio of the Trade (in US$) of Grenada in 1993 to that in 1994?
Offer a terse response. 1.05. What is the ratio of the Trade (in US$) of New Caledonia in 1993 to that in 1994?
Make the answer very short. 1.07. What is the ratio of the Trade (in US$) in Uruguay in 1993 to that in 1994?
Provide a succinct answer. 0.82. What is the ratio of the Trade (in US$) of Low income in 1993 to that in 1995?
Make the answer very short. 0.8. What is the ratio of the Trade (in US$) in Grenada in 1993 to that in 1995?
Offer a very short reply. 1.12. What is the ratio of the Trade (in US$) of New Caledonia in 1993 to that in 1995?
Your response must be concise. 0.97. What is the ratio of the Trade (in US$) of Uruguay in 1993 to that in 1995?
Give a very brief answer. 0.8. What is the ratio of the Trade (in US$) in Low income in 1993 to that in 1996?
Offer a terse response. 0.76. What is the ratio of the Trade (in US$) of Grenada in 1993 to that in 1996?
Keep it short and to the point. 0.88. What is the ratio of the Trade (in US$) in New Caledonia in 1993 to that in 1996?
Your answer should be very brief. 0.93. What is the ratio of the Trade (in US$) in Uruguay in 1993 to that in 1996?
Give a very brief answer. 0.72. What is the ratio of the Trade (in US$) of Low income in 1993 to that in 1997?
Provide a short and direct response. 0.77. What is the ratio of the Trade (in US$) in Grenada in 1993 to that in 1997?
Give a very brief answer. 0.8. What is the ratio of the Trade (in US$) of Uruguay in 1993 to that in 1997?
Keep it short and to the point. 0.6. What is the ratio of the Trade (in US$) of Low income in 1994 to that in 1995?
Make the answer very short. 0.84. What is the ratio of the Trade (in US$) in Grenada in 1994 to that in 1995?
Give a very brief answer. 1.07. What is the ratio of the Trade (in US$) of New Caledonia in 1994 to that in 1995?
Provide a short and direct response. 0.9. What is the ratio of the Trade (in US$) in Uruguay in 1994 to that in 1995?
Make the answer very short. 0.97. What is the ratio of the Trade (in US$) of Low income in 1994 to that in 1996?
Ensure brevity in your answer.  0.8. What is the ratio of the Trade (in US$) in Grenada in 1994 to that in 1996?
Your answer should be compact. 0.84. What is the ratio of the Trade (in US$) of New Caledonia in 1994 to that in 1996?
Ensure brevity in your answer.  0.86. What is the ratio of the Trade (in US$) of Uruguay in 1994 to that in 1996?
Make the answer very short. 0.87. What is the ratio of the Trade (in US$) in Low income in 1994 to that in 1997?
Offer a very short reply. 0.81. What is the ratio of the Trade (in US$) of Grenada in 1994 to that in 1997?
Make the answer very short. 0.77. What is the ratio of the Trade (in US$) in New Caledonia in 1994 to that in 1997?
Ensure brevity in your answer.  0.93. What is the ratio of the Trade (in US$) of Uruguay in 1994 to that in 1997?
Your response must be concise. 0.73. What is the ratio of the Trade (in US$) of Low income in 1995 to that in 1996?
Your answer should be very brief. 0.96. What is the ratio of the Trade (in US$) of Grenada in 1995 to that in 1996?
Offer a terse response. 0.79. What is the ratio of the Trade (in US$) in New Caledonia in 1995 to that in 1996?
Your response must be concise. 0.96. What is the ratio of the Trade (in US$) of Uruguay in 1995 to that in 1996?
Your answer should be compact. 0.9. What is the ratio of the Trade (in US$) of Low income in 1995 to that in 1997?
Ensure brevity in your answer.  0.96. What is the ratio of the Trade (in US$) in Grenada in 1995 to that in 1997?
Provide a short and direct response. 0.72. What is the ratio of the Trade (in US$) of New Caledonia in 1995 to that in 1997?
Make the answer very short. 1.03. What is the ratio of the Trade (in US$) of Uruguay in 1995 to that in 1997?
Offer a very short reply. 0.76. What is the ratio of the Trade (in US$) in Low income in 1996 to that in 1997?
Ensure brevity in your answer.  1. What is the ratio of the Trade (in US$) in Grenada in 1996 to that in 1997?
Your answer should be compact. 0.91. What is the ratio of the Trade (in US$) in New Caledonia in 1996 to that in 1997?
Keep it short and to the point. 1.08. What is the ratio of the Trade (in US$) of Uruguay in 1996 to that in 1997?
Your answer should be very brief. 0.84. What is the difference between the highest and the second highest Trade (in US$) in Low income?
Offer a very short reply. 1.24e+08. What is the difference between the highest and the second highest Trade (in US$) in Grenada?
Give a very brief answer. 1.94e+07. What is the difference between the highest and the second highest Trade (in US$) of New Caledonia?
Your response must be concise. 4.34e+07. What is the difference between the highest and the second highest Trade (in US$) of Uruguay?
Your answer should be very brief. 7.79e+08. What is the difference between the highest and the lowest Trade (in US$) in Low income?
Offer a very short reply. 7.18e+09. What is the difference between the highest and the lowest Trade (in US$) in Grenada?
Ensure brevity in your answer.  7.43e+07. What is the difference between the highest and the lowest Trade (in US$) in New Caledonia?
Your response must be concise. 1.36e+08. What is the difference between the highest and the lowest Trade (in US$) of Uruguay?
Give a very brief answer. 3.17e+09. 